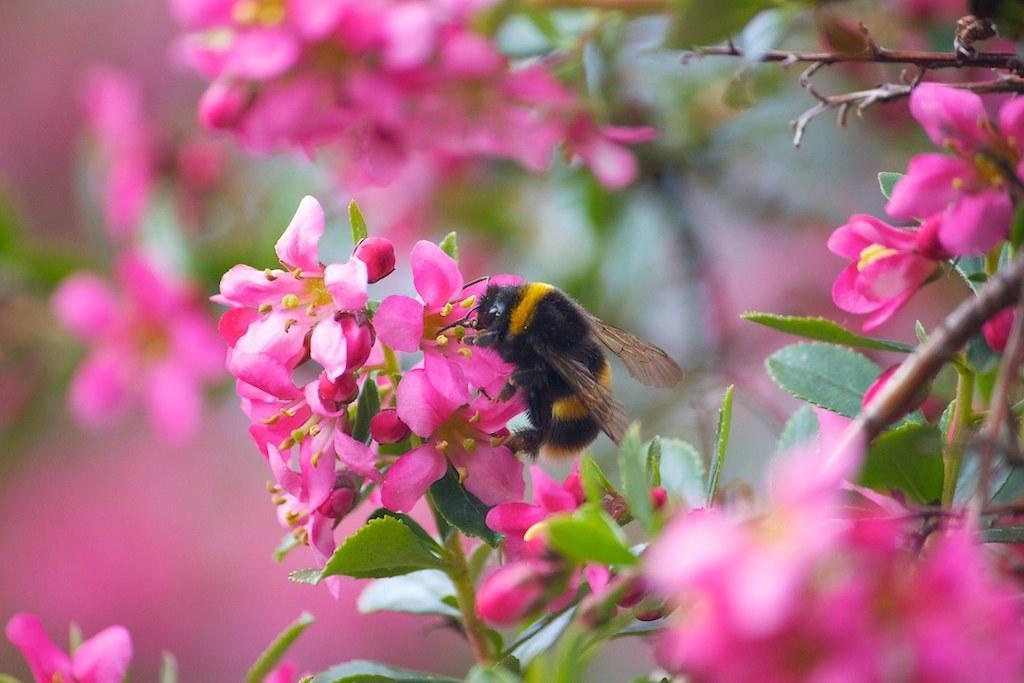How would you summarize this image in a sentence or two? In this picture we can see an insect on some pink flowers. 